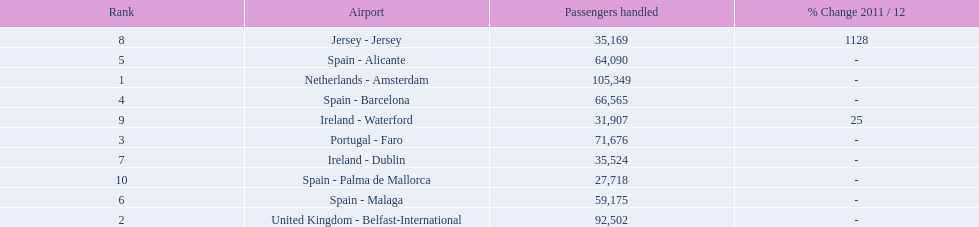What are the numbers of passengers handled along the different routes in the airport? 105,349, 92,502, 71,676, 66,565, 64,090, 59,175, 35,524, 35,169, 31,907, 27,718. Of these routes, which handles less than 30,000 passengers? Spain - Palma de Mallorca. 